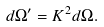<formula> <loc_0><loc_0><loc_500><loc_500>d \Omega ^ { \prime } = K ^ { 2 } d \Omega .</formula> 